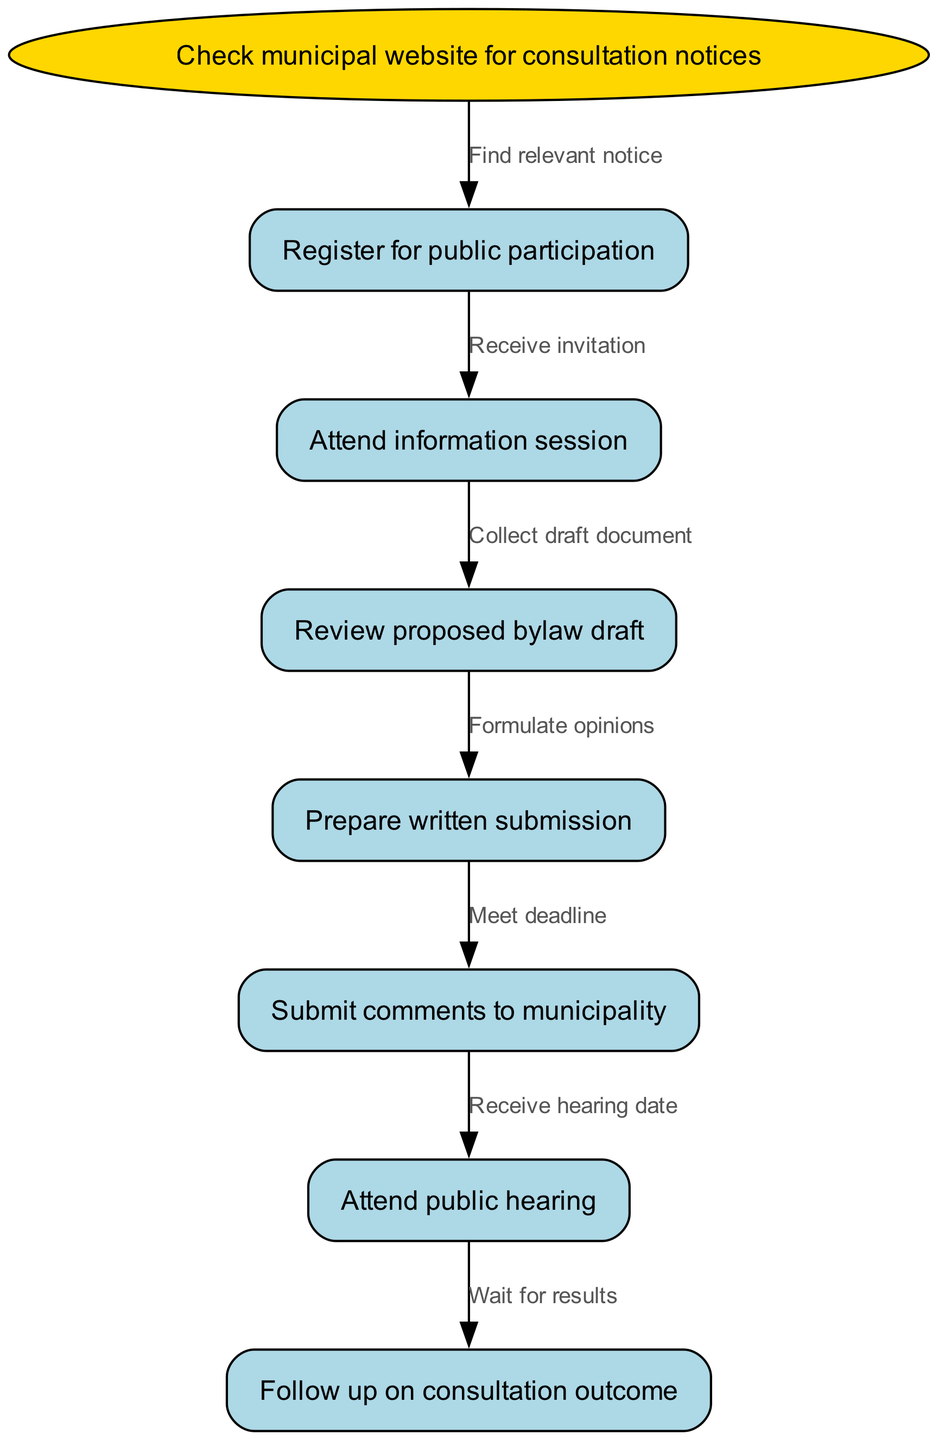What is the start node of the consultation process? The start node in the flow chart is clearly labeled as "Check municipal website for consultation notices," indicating that this is the initial action.
Answer: Check municipal website for consultation notices How many nodes are in total in the diagram? The diagram includes one start node and six additional nodes for various steps, totaling seven nodes in the flow chart.
Answer: 7 What is the first step after checking the municipal website? After "Check municipal website for consultation notices," the flow indicates the next step is "Register for public participation," establishing the sequence of actions participants need to take.
Answer: Register for public participation Which node directly follows the "Prepare written submission"? The flow shows that "Submit comments to municipality" comes directly after "Prepare written submission," depicting the pathway participants follow when making submissions.
Answer: Submit comments to municipality What is required to progress from "Review proposed bylaw draft" to the next step? To move from "Review proposed bylaw draft" to "Prepare written submission," the diagram indicates that participants need to "Formulate opinions," implying the necessity of thought and analysis before making a submission.
Answer: Formulate opinions What is the last step in the consultation process? According to the diagram, "Follow up on consultation outcome" is the final step, showing that participants should check the results after engaging in the earlier steps of the process.
Answer: Follow up on consultation outcome How many edges are there in the flow diagram? By counting the connections between the nodes, the diagram presents six edges that illustrate the flow between the various steps of the consultation process.
Answer: 6 What is the label on the edge from "Attend information session" to "Review proposed bylaw draft"? The edge from "Attend information session" to "Review proposed bylaw draft" is labeled "Collect draft document," indicating the action taken between these two steps.
Answer: Collect draft document What do participants need to have ready before they can "Submit comments to municipality"? Before "Submit comments to municipality," participants must "Meet deadline," as indicated, which emphasizes the importance of time management in the consultation process.
Answer: Meet deadline 